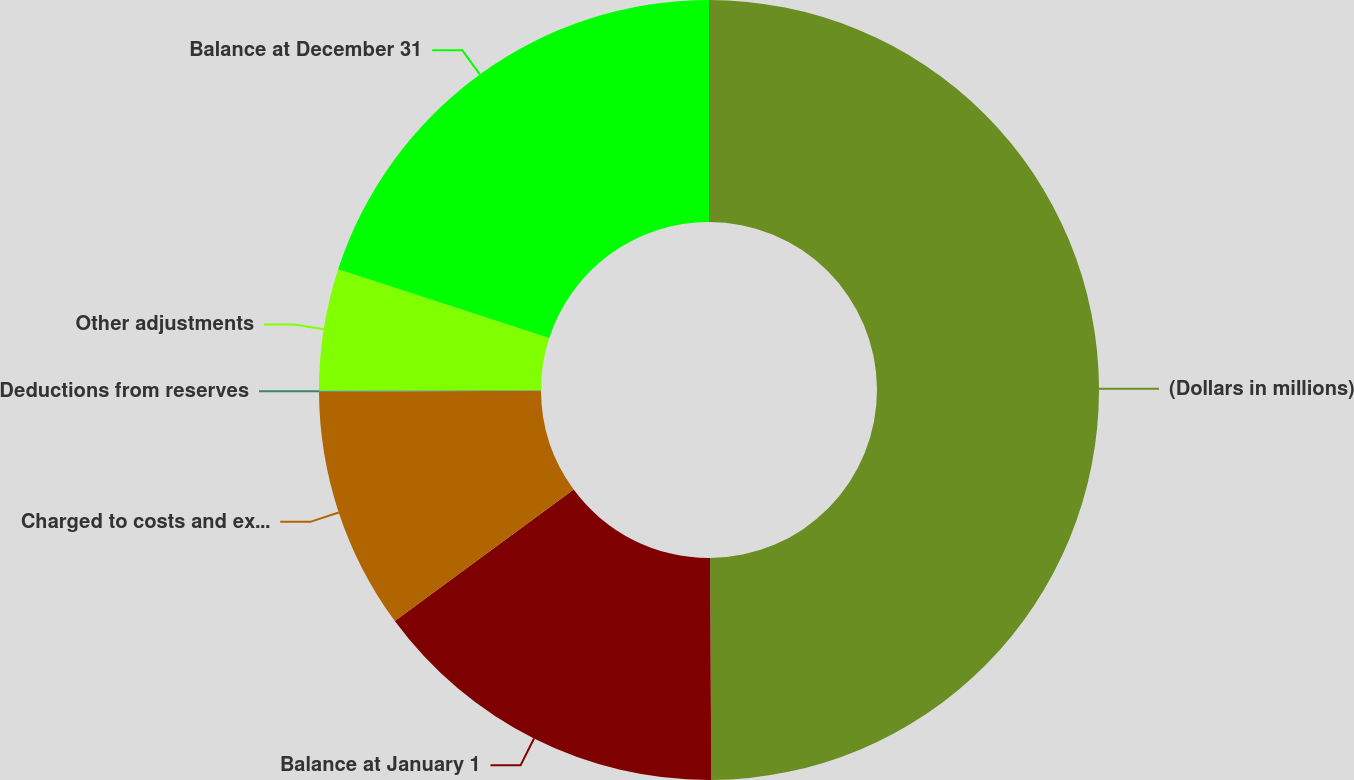<chart> <loc_0><loc_0><loc_500><loc_500><pie_chart><fcel>(Dollars in millions)<fcel>Balance at January 1<fcel>Charged to costs and expenses<fcel>Deductions from reserves<fcel>Other adjustments<fcel>Balance at December 31<nl><fcel>49.9%<fcel>15.0%<fcel>10.02%<fcel>0.05%<fcel>5.03%<fcel>19.99%<nl></chart> 